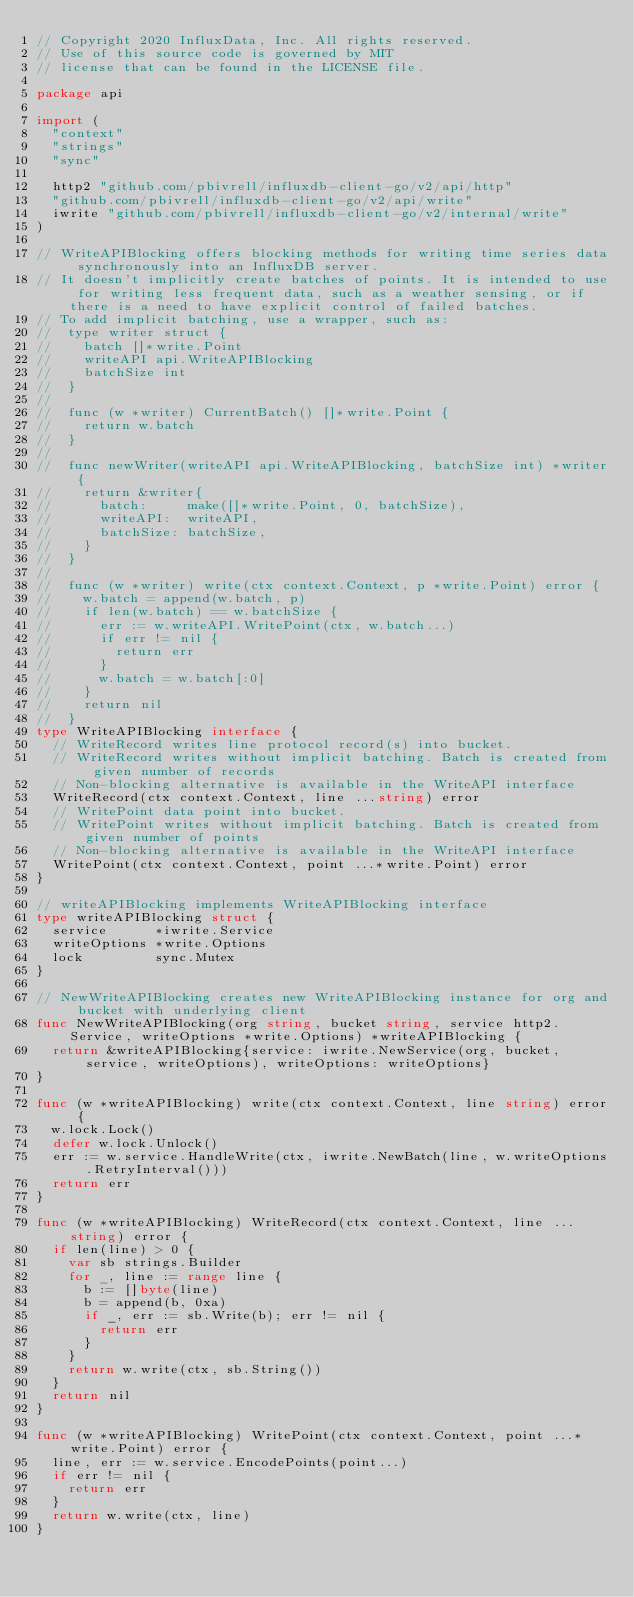Convert code to text. <code><loc_0><loc_0><loc_500><loc_500><_Go_>// Copyright 2020 InfluxData, Inc. All rights reserved.
// Use of this source code is governed by MIT
// license that can be found in the LICENSE file.

package api

import (
	"context"
	"strings"
	"sync"

	http2 "github.com/pbivrell/influxdb-client-go/v2/api/http"
	"github.com/pbivrell/influxdb-client-go/v2/api/write"
	iwrite "github.com/pbivrell/influxdb-client-go/v2/internal/write"
)

// WriteAPIBlocking offers blocking methods for writing time series data synchronously into an InfluxDB server.
// It doesn't implicitly create batches of points. It is intended to use for writing less frequent data, such as a weather sensing, or if there is a need to have explicit control of failed batches.
// To add implicit batching, use a wrapper, such as:
//	type writer struct {
//		batch []*write.Point
//		writeAPI api.WriteAPIBlocking
//		batchSize int
//	}
//
//	func (w *writer) CurrentBatch() []*write.Point {
//		return w.batch
//	}
//
//	func newWriter(writeAPI api.WriteAPIBlocking, batchSize int) *writer {
//		return &writer{
//			batch:     make([]*write.Point, 0, batchSize),
//			writeAPI:  writeAPI,
//			batchSize: batchSize,
//		}
//	}
//
//	func (w *writer) write(ctx context.Context, p *write.Point) error {
//		w.batch = append(w.batch, p)
//		if len(w.batch) == w.batchSize {
//			err := w.writeAPI.WritePoint(ctx, w.batch...)
//			if err != nil {
//				return err
//			}
//			w.batch = w.batch[:0]
//		}
//		return nil
//	}
type WriteAPIBlocking interface {
	// WriteRecord writes line protocol record(s) into bucket.
	// WriteRecord writes without implicit batching. Batch is created from given number of records
	// Non-blocking alternative is available in the WriteAPI interface
	WriteRecord(ctx context.Context, line ...string) error
	// WritePoint data point into bucket.
	// WritePoint writes without implicit batching. Batch is created from given number of points
	// Non-blocking alternative is available in the WriteAPI interface
	WritePoint(ctx context.Context, point ...*write.Point) error
}

// writeAPIBlocking implements WriteAPIBlocking interface
type writeAPIBlocking struct {
	service      *iwrite.Service
	writeOptions *write.Options
	lock         sync.Mutex
}

// NewWriteAPIBlocking creates new WriteAPIBlocking instance for org and bucket with underlying client
func NewWriteAPIBlocking(org string, bucket string, service http2.Service, writeOptions *write.Options) *writeAPIBlocking {
	return &writeAPIBlocking{service: iwrite.NewService(org, bucket, service, writeOptions), writeOptions: writeOptions}
}

func (w *writeAPIBlocking) write(ctx context.Context, line string) error {
	w.lock.Lock()
	defer w.lock.Unlock()
	err := w.service.HandleWrite(ctx, iwrite.NewBatch(line, w.writeOptions.RetryInterval()))
	return err
}

func (w *writeAPIBlocking) WriteRecord(ctx context.Context, line ...string) error {
	if len(line) > 0 {
		var sb strings.Builder
		for _, line := range line {
			b := []byte(line)
			b = append(b, 0xa)
			if _, err := sb.Write(b); err != nil {
				return err
			}
		}
		return w.write(ctx, sb.String())
	}
	return nil
}

func (w *writeAPIBlocking) WritePoint(ctx context.Context, point ...*write.Point) error {
	line, err := w.service.EncodePoints(point...)
	if err != nil {
		return err
	}
	return w.write(ctx, line)
}
</code> 